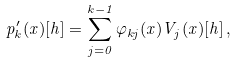<formula> <loc_0><loc_0><loc_500><loc_500>p _ { k } ^ { \prime } ( x ) [ h ] = \sum _ { j = 0 } ^ { k - 1 } \varphi _ { k j } ( x ) V _ { j } ( x ) [ h ] \, ,</formula> 